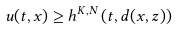Convert formula to latex. <formula><loc_0><loc_0><loc_500><loc_500>u ( t , x ) \geq h ^ { K , N } \left ( t , d ( x , z ) \right )</formula> 